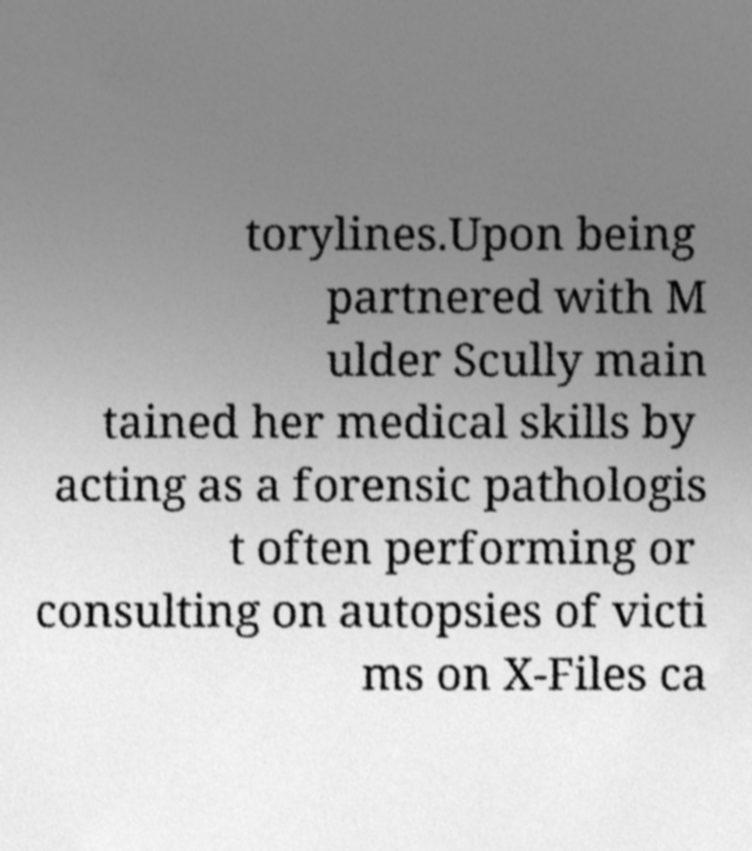For documentation purposes, I need the text within this image transcribed. Could you provide that? torylines.Upon being partnered with M ulder Scully main tained her medical skills by acting as a forensic pathologis t often performing or consulting on autopsies of victi ms on X-Files ca 